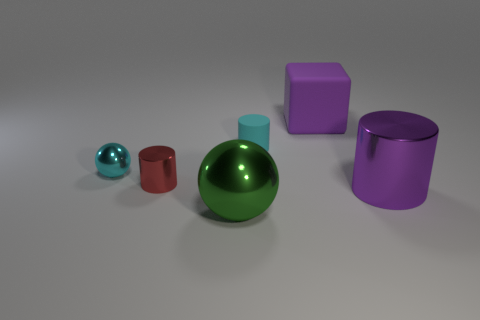Are there any large metal things that have the same color as the large cylinder?
Your response must be concise. No. There is a small metallic thing behind the tiny red metal cylinder; is it the same color as the metallic thing on the right side of the green sphere?
Make the answer very short. No. There is a metallic object that is the same color as the big cube; what is its size?
Provide a succinct answer. Large. Are there any small red objects that have the same material as the red cylinder?
Give a very brief answer. No. The small metal cylinder has what color?
Give a very brief answer. Red. What size is the purple object in front of the cylinder behind the tiny shiny cylinder behind the purple metal thing?
Ensure brevity in your answer.  Large. How many other objects are the same shape as the purple metal thing?
Give a very brief answer. 2. There is a cylinder that is on the right side of the big green shiny ball and behind the purple metallic thing; what is its color?
Give a very brief answer. Cyan. Is there anything else that has the same size as the purple block?
Provide a succinct answer. Yes. There is a big metallic object that is on the left side of the small cyan rubber object; is it the same color as the large rubber thing?
Provide a succinct answer. No. 